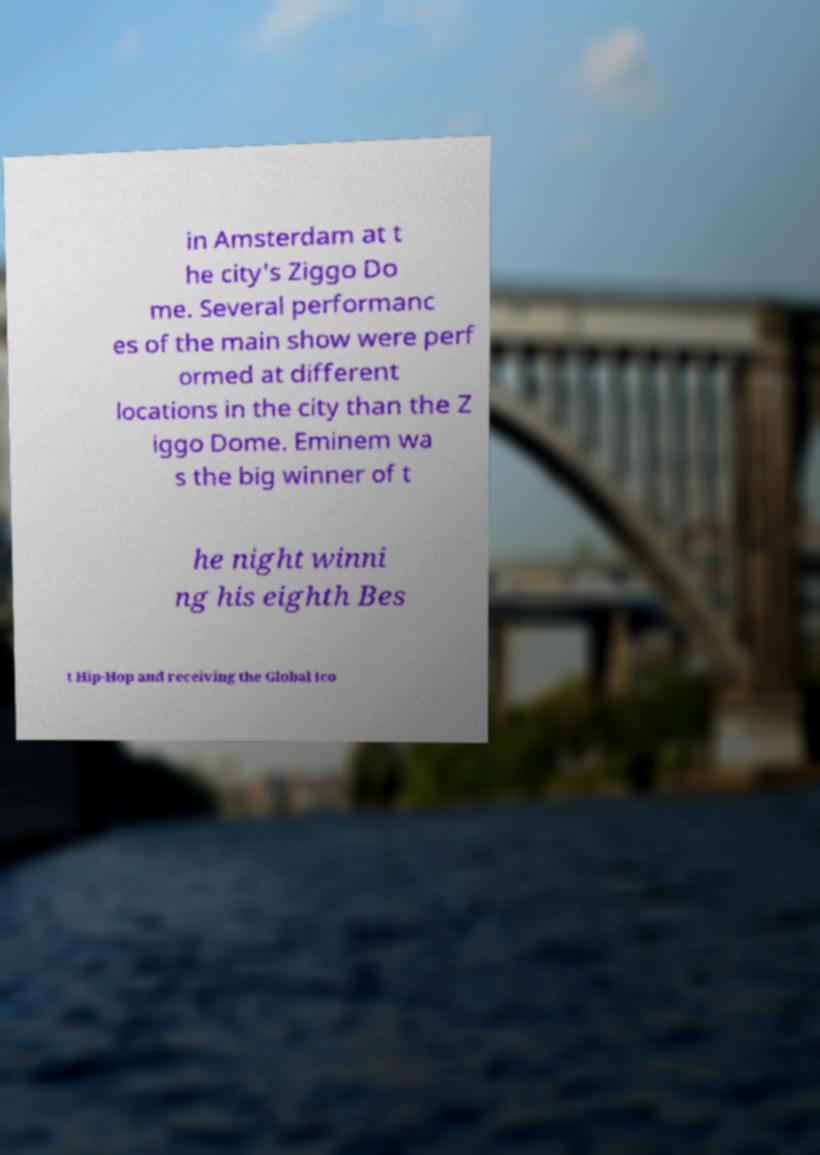I need the written content from this picture converted into text. Can you do that? in Amsterdam at t he city's Ziggo Do me. Several performanc es of the main show were perf ormed at different locations in the city than the Z iggo Dome. Eminem wa s the big winner of t he night winni ng his eighth Bes t Hip-Hop and receiving the Global Ico 